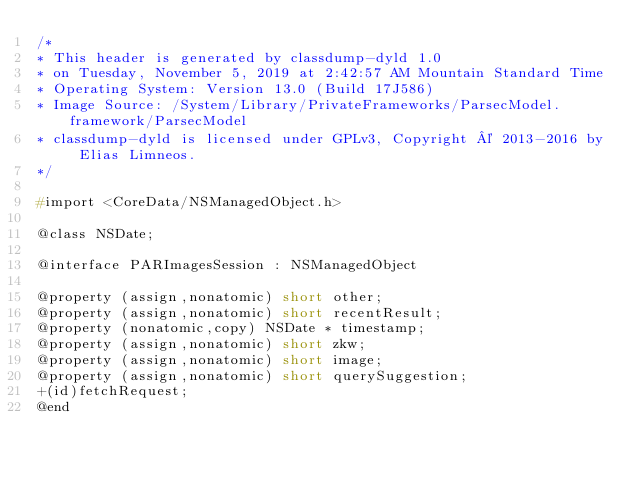<code> <loc_0><loc_0><loc_500><loc_500><_C_>/*
* This header is generated by classdump-dyld 1.0
* on Tuesday, November 5, 2019 at 2:42:57 AM Mountain Standard Time
* Operating System: Version 13.0 (Build 17J586)
* Image Source: /System/Library/PrivateFrameworks/ParsecModel.framework/ParsecModel
* classdump-dyld is licensed under GPLv3, Copyright © 2013-2016 by Elias Limneos.
*/

#import <CoreData/NSManagedObject.h>

@class NSDate;

@interface PARImagesSession : NSManagedObject

@property (assign,nonatomic) short other; 
@property (assign,nonatomic) short recentResult; 
@property (nonatomic,copy) NSDate * timestamp; 
@property (assign,nonatomic) short zkw; 
@property (assign,nonatomic) short image; 
@property (assign,nonatomic) short querySuggestion; 
+(id)fetchRequest;
@end

</code> 